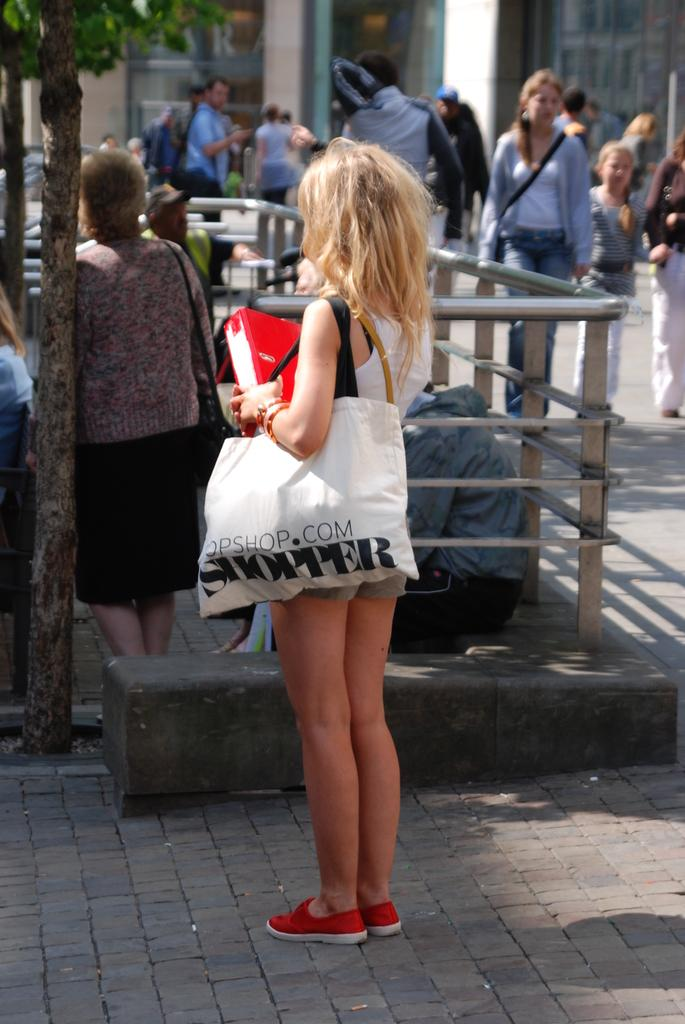<image>
Relay a brief, clear account of the picture shown. A young girl with blonde hair standing on the sidewalk holding a white bag that says SHOPPER. 